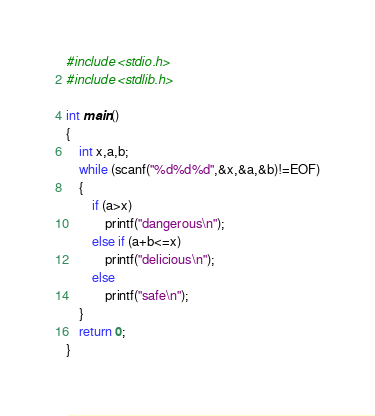Convert code to text. <code><loc_0><loc_0><loc_500><loc_500><_C_>#include <stdio.h>
#include <stdlib.h>

int main()
{
    int x,a,b;
    while (scanf("%d%d%d",&x,&a,&b)!=EOF)
    {
        if (a>x)
            printf("dangerous\n");
        else if (a+b<=x)
            printf("delicious\n");
        else
            printf("safe\n");
    }
    return 0;
}</code> 